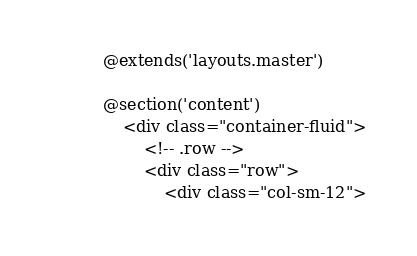<code> <loc_0><loc_0><loc_500><loc_500><_PHP_>@extends('layouts.master')

@section('content')
    <div class="container-fluid">
        <!-- .row -->
        <div class="row">
            <div class="col-sm-12"></code> 